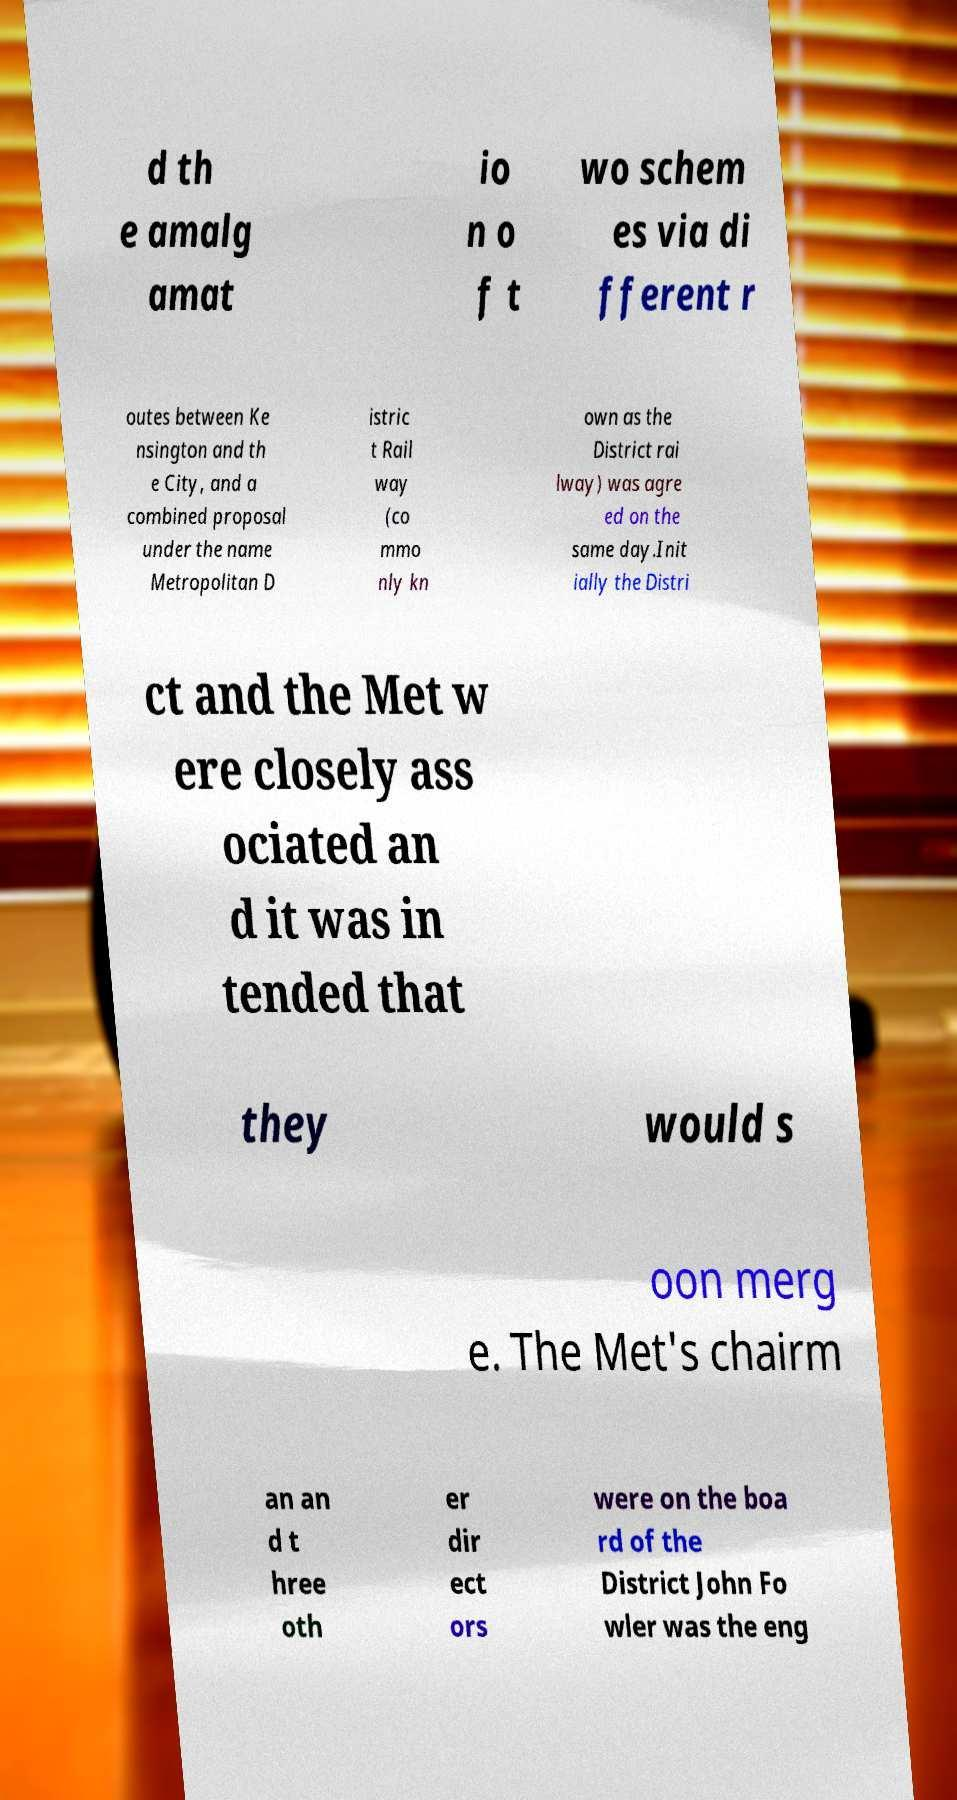Please read and relay the text visible in this image. What does it say? d th e amalg amat io n o f t wo schem es via di fferent r outes between Ke nsington and th e City, and a combined proposal under the name Metropolitan D istric t Rail way (co mmo nly kn own as the District rai lway) was agre ed on the same day.Init ially the Distri ct and the Met w ere closely ass ociated an d it was in tended that they would s oon merg e. The Met's chairm an an d t hree oth er dir ect ors were on the boa rd of the District John Fo wler was the eng 